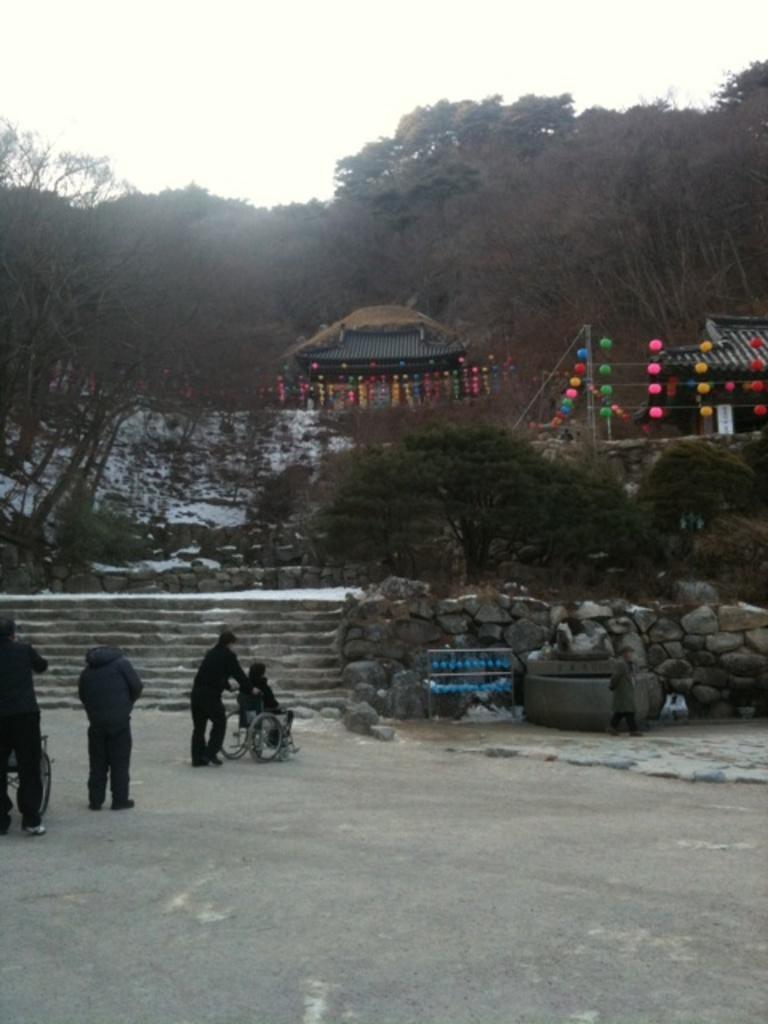How would you summarize this image in a sentence or two? There are few persons and this is a road. In the background we can see trees, huts, decorative items, and sky. 